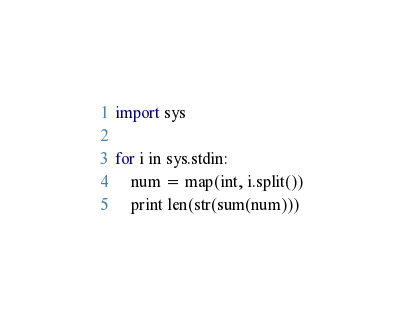Convert code to text. <code><loc_0><loc_0><loc_500><loc_500><_Python_>import sys

for i in sys.stdin:
    num = map(int, i.split())
    print len(str(sum(num)))</code> 